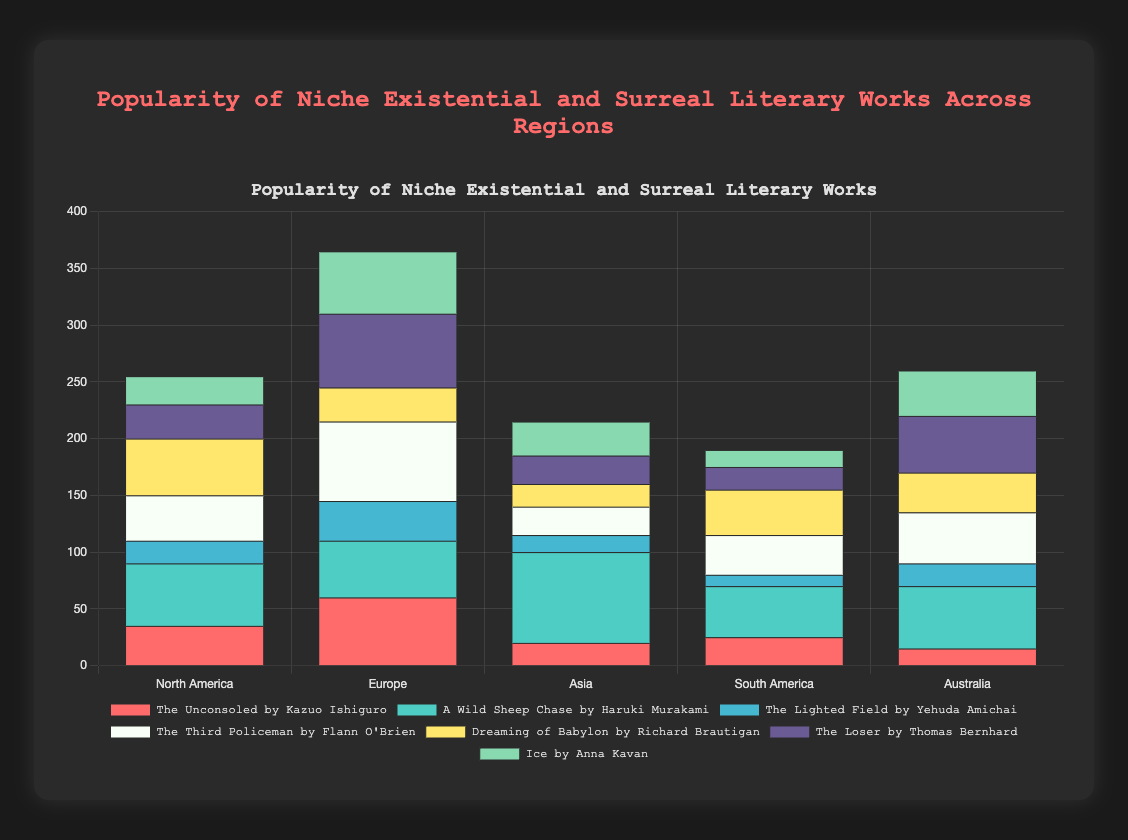Which region has the highest popularity for "A Wild Sheep Chase by Haruki Murakami"? Looking at the bars representing "A Wild Sheep Chase by Haruki Murakami" (colored in green), we observe that Asia has the tallest bar, showing the highest popularity.
Answer: Asia Which work has the least popularity in South America? By examining the height of the bars for each work in South America, we see that "The Lighted Field by Yehuda Amichai" (colored in blue) has the shortest bar.
Answer: The Lighted Field by Yehuda Amichai What is the total popularity of "The Third Policeman by Flann O'Brien" across all regions? Summing up the values from each region for "The Third Policeman by Flann O'Brien" (North America: 40, Europe: 70, Asia: 25, South America: 35, Australia: 45), we get 40 + 70 + 25 + 35 + 45 = 215.
Answer: 215 Which region shows the greatest disparity in popularity between "The Unconsoled by Kazuo Ishiguro" and "The Third Policeman by Flann O'Brien"? Calculating the difference in popularity for each region: North America (40-35=5), Europe (70-60=10), Asia (25-20=5), South America (35-25=10), Australia (45-15=30). Australia has the greatest disparity.
Answer: Australia How does the popularity of "The Loser by Thomas Bernhard" in North America compare to that in Australia? Comparing the heights of the bars for "The Loser by Thomas Bernhard," we see that the bar in Australia is taller (50) than in North America (30).
Answer: Higher Which work has the second highest popularity in Europe? In Europe, "The Third Policeman by Flann O'Brien" has the highest popularity (70), followed by "The Loser by Thomas Bernhard" (65).
Answer: The Loser by Thomas Bernhard What is the average popularity of "Ice by Anna Kavan" across all regions? Summing the popularity in each region (25 + 55 + 30 + 15 + 40) gives 165. Dividing by the number of regions (5), the average is 165/5 = 33.
Answer: 33 Between "Dreaming of Babylon by Richard Brautigan" and "The Lighted Field by Yehuda Amichai," which has a higher total popularity across all regions? Summing their respective popularities: "Dreaming of Babylon by Richard Brautigan" (North America: 50, Europe: 30, Asia: 20, South America: 40, Australia: 35) = 175. "The Lighted Field by Yehuda Amichai" (North America: 20, Europe: 35, Asia: 15, South America: 10, Australia: 20) = 100. "Dreaming of Babylon by Richard Brautigan" has a higher total popularity.
Answer: Dreaming of Babylon by Richard Brautigan Which region has the highest combined popularity for all the works? Calculating the total popularity for each region: North America (35+55+20+40+50+30+25 = 255), Europe (60+50+35+70+30+65+55 = 365), Asia (20+80+15+25+20+25+30 = 215), South America (25+45+10+35+40+20+15 = 190), Australia (15+55+20+45+35+50+40 = 260). Europe has the highest combined popularity.
Answer: Europe What are the three most popular works in North America? Sorting the popularity values in North America, we find "A Wild Sheep Chase by Haruki Murakami" (55), "Dreaming of Babylon by Richard Brautigan" (50), and "The Third Policeman by Flann O'Brien" (40) are the top three.
Answer: A Wild Sheep Chase by Haruki Murakami, Dreaming of Babylon by Richard Brautigan, The Third Policeman by Flann O'Brien 